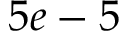<formula> <loc_0><loc_0><loc_500><loc_500>5 e - 5</formula> 